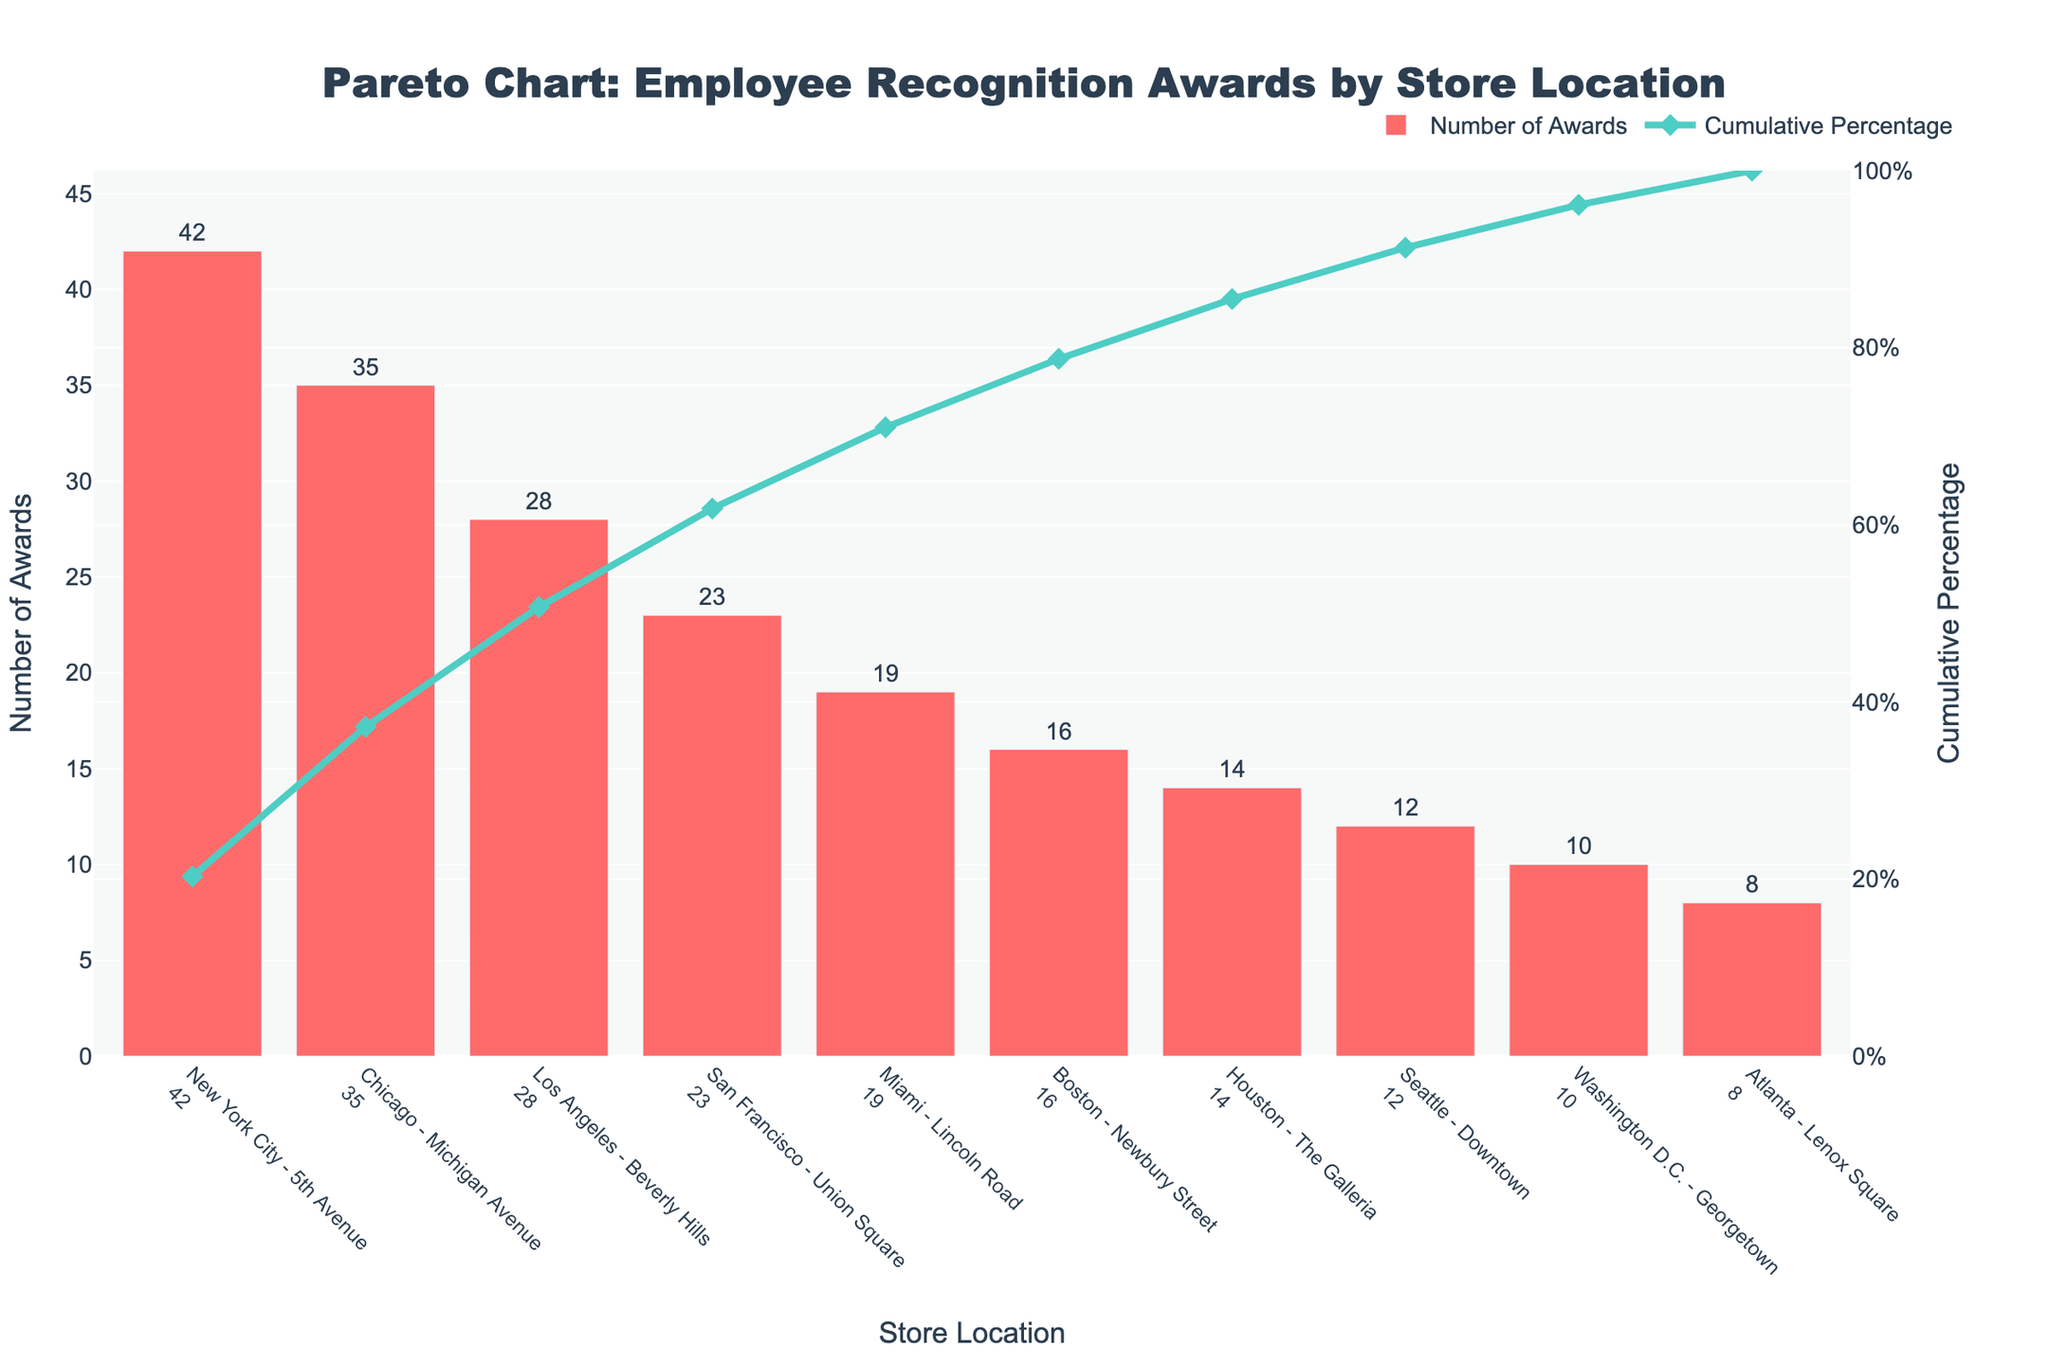Which store location received the most awards? The store that received the most awards can be identified by looking at the highest bar in the chart.
Answer: New York City - 5th Avenue What's the title of the chart? The title is typically displayed at the top of the chart.
Answer: Pareto Chart: Employee Recognition Awards by Store Location How many awards were distributed by the store location with the fewest awards? The store with the fewest awards has the shortest bar in the chart.
Answer: 8 awards were distributed by the Atlanta - Lenox Square store What is the cumulative percentage for Los Angeles - Beverly Hills? The cumulative percentage for Los Angeles - Beverly Hills can be found by looking at the corresponding point on the cumulative percentage line.
Answer: 66.7% By how many awards does the New York City - 5th Avenue store exceed the Chicago - Michigan Avenue store? To find the difference, subtract the number of awards received by the Chicago - Michigan Avenue store from the number received by the New York City - 5th Avenue store. 42 - 35 = 7
Answer: 7 awards Which store locations have a cumulative percentage above 80%? Identify the points on the cumulative percentage line where the value exceeds 80%.Then, check which store locations correspond to these points.
Answer: San Francisco - Union Square, and all locations before it What color is used for the bars representing the number of awards, and for the line representing the cumulative percentage? The color of the bars and the line can be identified from the chart.
Answer: Bars: red, Line: teal Is the number of awards for Seattle - Downtown greater or less than for Houston - The Galleria? Compare the heights of the bars representing Seattle - Downtown and Houston - The Galleria.
Answer: Less What's the average number of awards distributed across all store locations? Sum the number of awards for all locations and divide by the number of locations: (42 + 35 + 28 + 23 + 19 + 16 + 14 + 12 + 10 + 8) / 10 = 20.7
Answer: 20.7 How many store locations were presented in the chart? Count the number of bars/categorical labels on the x-axis.
Answer: 10 